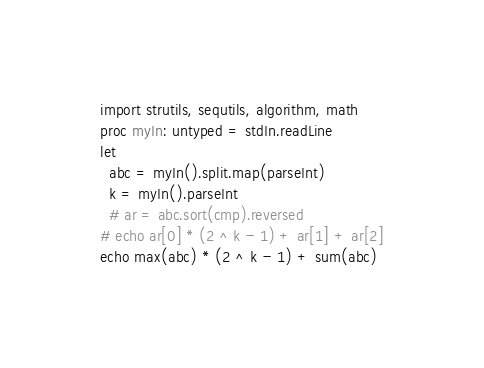Convert code to text. <code><loc_0><loc_0><loc_500><loc_500><_Nim_>import strutils, sequtils, algorithm, math
proc myIn: untyped = stdIn.readLine
let
  abc = myIn().split.map(parseInt)
  k = myIn().parseInt
  # ar = abc.sort(cmp).reversed
# echo ar[0] * (2 ^ k - 1) + ar[1] + ar[2]
echo max(abc) * (2 ^ k - 1) + sum(abc)
</code> 